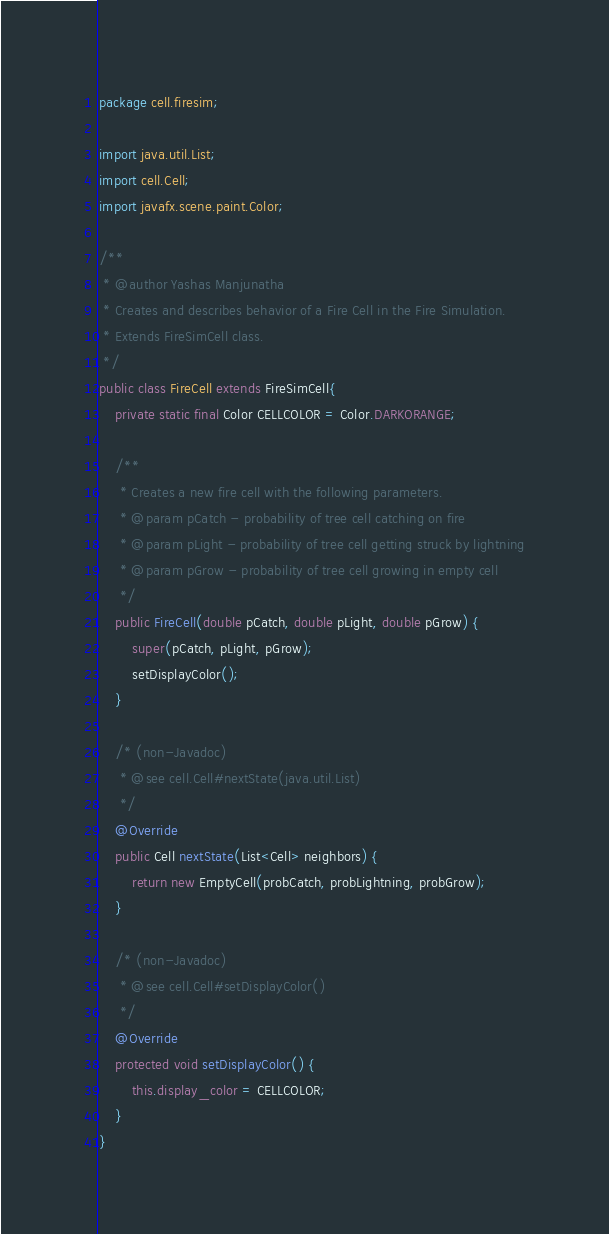Convert code to text. <code><loc_0><loc_0><loc_500><loc_500><_Java_>package cell.firesim;

import java.util.List;
import cell.Cell;
import javafx.scene.paint.Color;

/**
 * @author Yashas Manjunatha
 * Creates and describes behavior of a Fire Cell in the Fire Simulation.
 * Extends FireSimCell class.
 */
public class FireCell extends FireSimCell{
	private static final Color CELLCOLOR = Color.DARKORANGE;

	/**
	 * Creates a new fire cell with the following parameters.
	 * @param pCatch - probability of tree cell catching on fire
	 * @param pLight - probability of tree cell getting struck by lightning
	 * @param pGrow - probability of tree cell growing in empty cell
	 */
	public FireCell(double pCatch, double pLight, double pGrow) {
		super(pCatch, pLight, pGrow);
		setDisplayColor();
	}

	/* (non-Javadoc)
	 * @see cell.Cell#nextState(java.util.List)
	 */
	@Override
	public Cell nextState(List<Cell> neighbors) {
		return new EmptyCell(probCatch, probLightning, probGrow);
	}

	/* (non-Javadoc)
	 * @see cell.Cell#setDisplayColor()
	 */
	@Override
	protected void setDisplayColor() {
		this.display_color = CELLCOLOR;
	}
}
</code> 